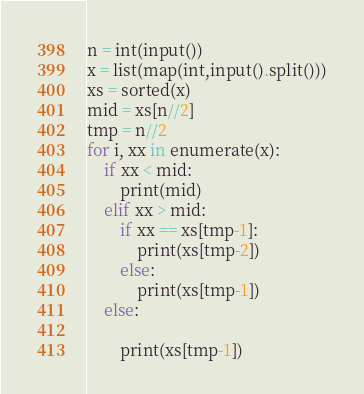<code> <loc_0><loc_0><loc_500><loc_500><_Python_>n = int(input())
x = list(map(int,input().split()))
xs = sorted(x)
mid = xs[n//2]
tmp = n//2
for i, xx in enumerate(x):
    if xx < mid:
        print(mid)
    elif xx > mid:
        if xx == xs[tmp-1]:
            print(xs[tmp-2])
        else:
            print(xs[tmp-1])
    else:

        print(xs[tmp-1])
</code> 